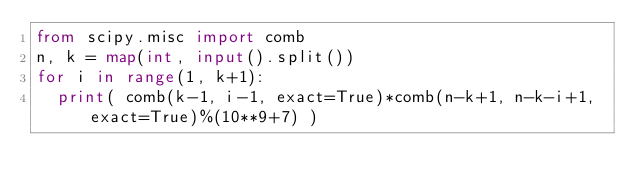Convert code to text. <code><loc_0><loc_0><loc_500><loc_500><_Python_>from scipy.misc import comb
n, k = map(int, input().split())
for i in range(1, k+1):
	print( comb(k-1, i-1, exact=True)*comb(n-k+1, n-k-i+1, exact=True)%(10**9+7) )
</code> 